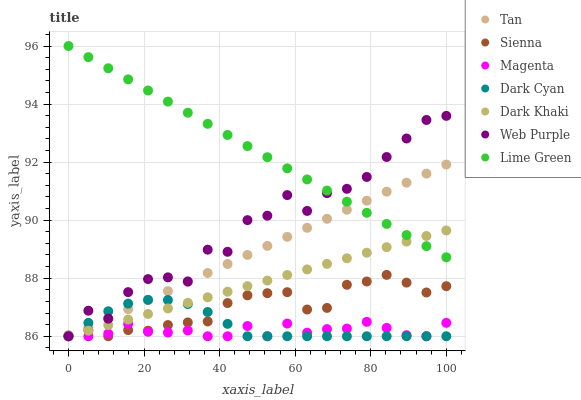Does Magenta have the minimum area under the curve?
Answer yes or no. Yes. Does Lime Green have the maximum area under the curve?
Answer yes or no. Yes. Does Sienna have the minimum area under the curve?
Answer yes or no. No. Does Sienna have the maximum area under the curve?
Answer yes or no. No. Is Dark Khaki the smoothest?
Answer yes or no. Yes. Is Web Purple the roughest?
Answer yes or no. Yes. Is Sienna the smoothest?
Answer yes or no. No. Is Sienna the roughest?
Answer yes or no. No. Does Dark Khaki have the lowest value?
Answer yes or no. Yes. Does Lime Green have the lowest value?
Answer yes or no. No. Does Lime Green have the highest value?
Answer yes or no. Yes. Does Sienna have the highest value?
Answer yes or no. No. Is Sienna less than Lime Green?
Answer yes or no. Yes. Is Lime Green greater than Magenta?
Answer yes or no. Yes. Does Tan intersect Dark Khaki?
Answer yes or no. Yes. Is Tan less than Dark Khaki?
Answer yes or no. No. Is Tan greater than Dark Khaki?
Answer yes or no. No. Does Sienna intersect Lime Green?
Answer yes or no. No. 